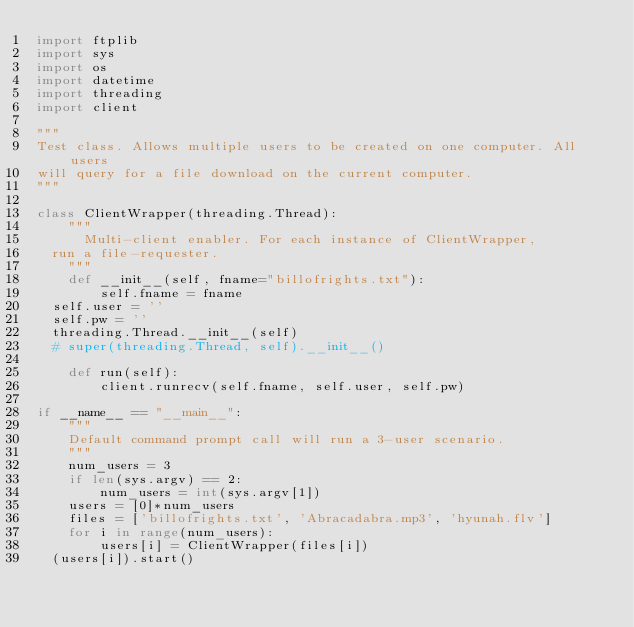<code> <loc_0><loc_0><loc_500><loc_500><_Python_>import ftplib
import sys
import os
import datetime
import threading
import client

"""
Test class. Allows multiple users to be created on one computer. All users
will query for a file download on the current computer.
"""

class ClientWrapper(threading.Thread):
    """
    	Multi-client enabler. For each instance of ClientWrapper,
	run a file-requester.
    """
    def __init__(self, fname="billofrights.txt"):
        self.fname = fname
	self.user = ''
	self.pw = ''
	threading.Thread.__init__(self)
	# super(threading.Thread, self).__init__()

    def run(self):
        client.runrecv(self.fname, self.user, self.pw)

if __name__ == "__main__":
    """
    Default command prompt call will run a 3-user scenario.
    """
    num_users = 3
    if len(sys.argv) == 2:
        num_users = int(sys.argv[1])
    users = [0]*num_users
    files = ['billofrights.txt', 'Abracadabra.mp3', 'hyunah.flv']
    for i in range(num_users):
        users[i] = ClientWrapper(files[i])
	(users[i]).start()
</code> 